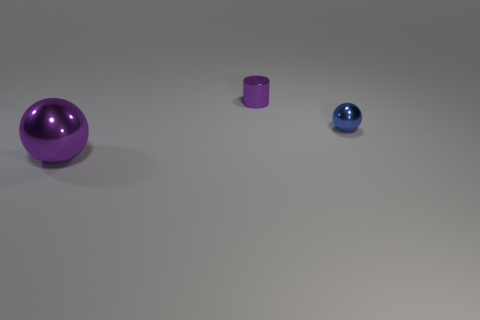Add 2 tiny blue balls. How many objects exist? 5 Subtract all cylinders. How many objects are left? 2 Add 3 purple cylinders. How many purple cylinders are left? 4 Add 2 tiny blue spheres. How many tiny blue spheres exist? 3 Subtract 0 red spheres. How many objects are left? 3 Subtract all tiny metallic spheres. Subtract all spheres. How many objects are left? 0 